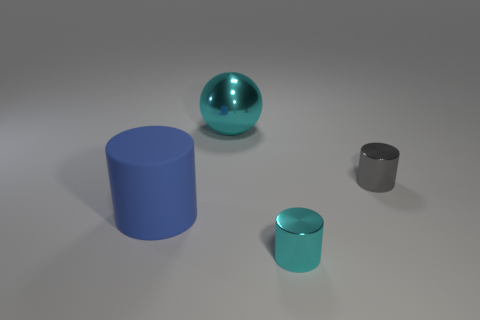Subtract 1 cylinders. How many cylinders are left? 2 Subtract all metallic cylinders. How many cylinders are left? 1 Add 2 big balls. How many objects exist? 6 Subtract all cylinders. How many objects are left? 1 Add 3 blue metallic cubes. How many blue metallic cubes exist? 3 Subtract 1 cyan cylinders. How many objects are left? 3 Subtract all cyan shiny cylinders. Subtract all cyan shiny things. How many objects are left? 1 Add 3 small gray metal cylinders. How many small gray metal cylinders are left? 4 